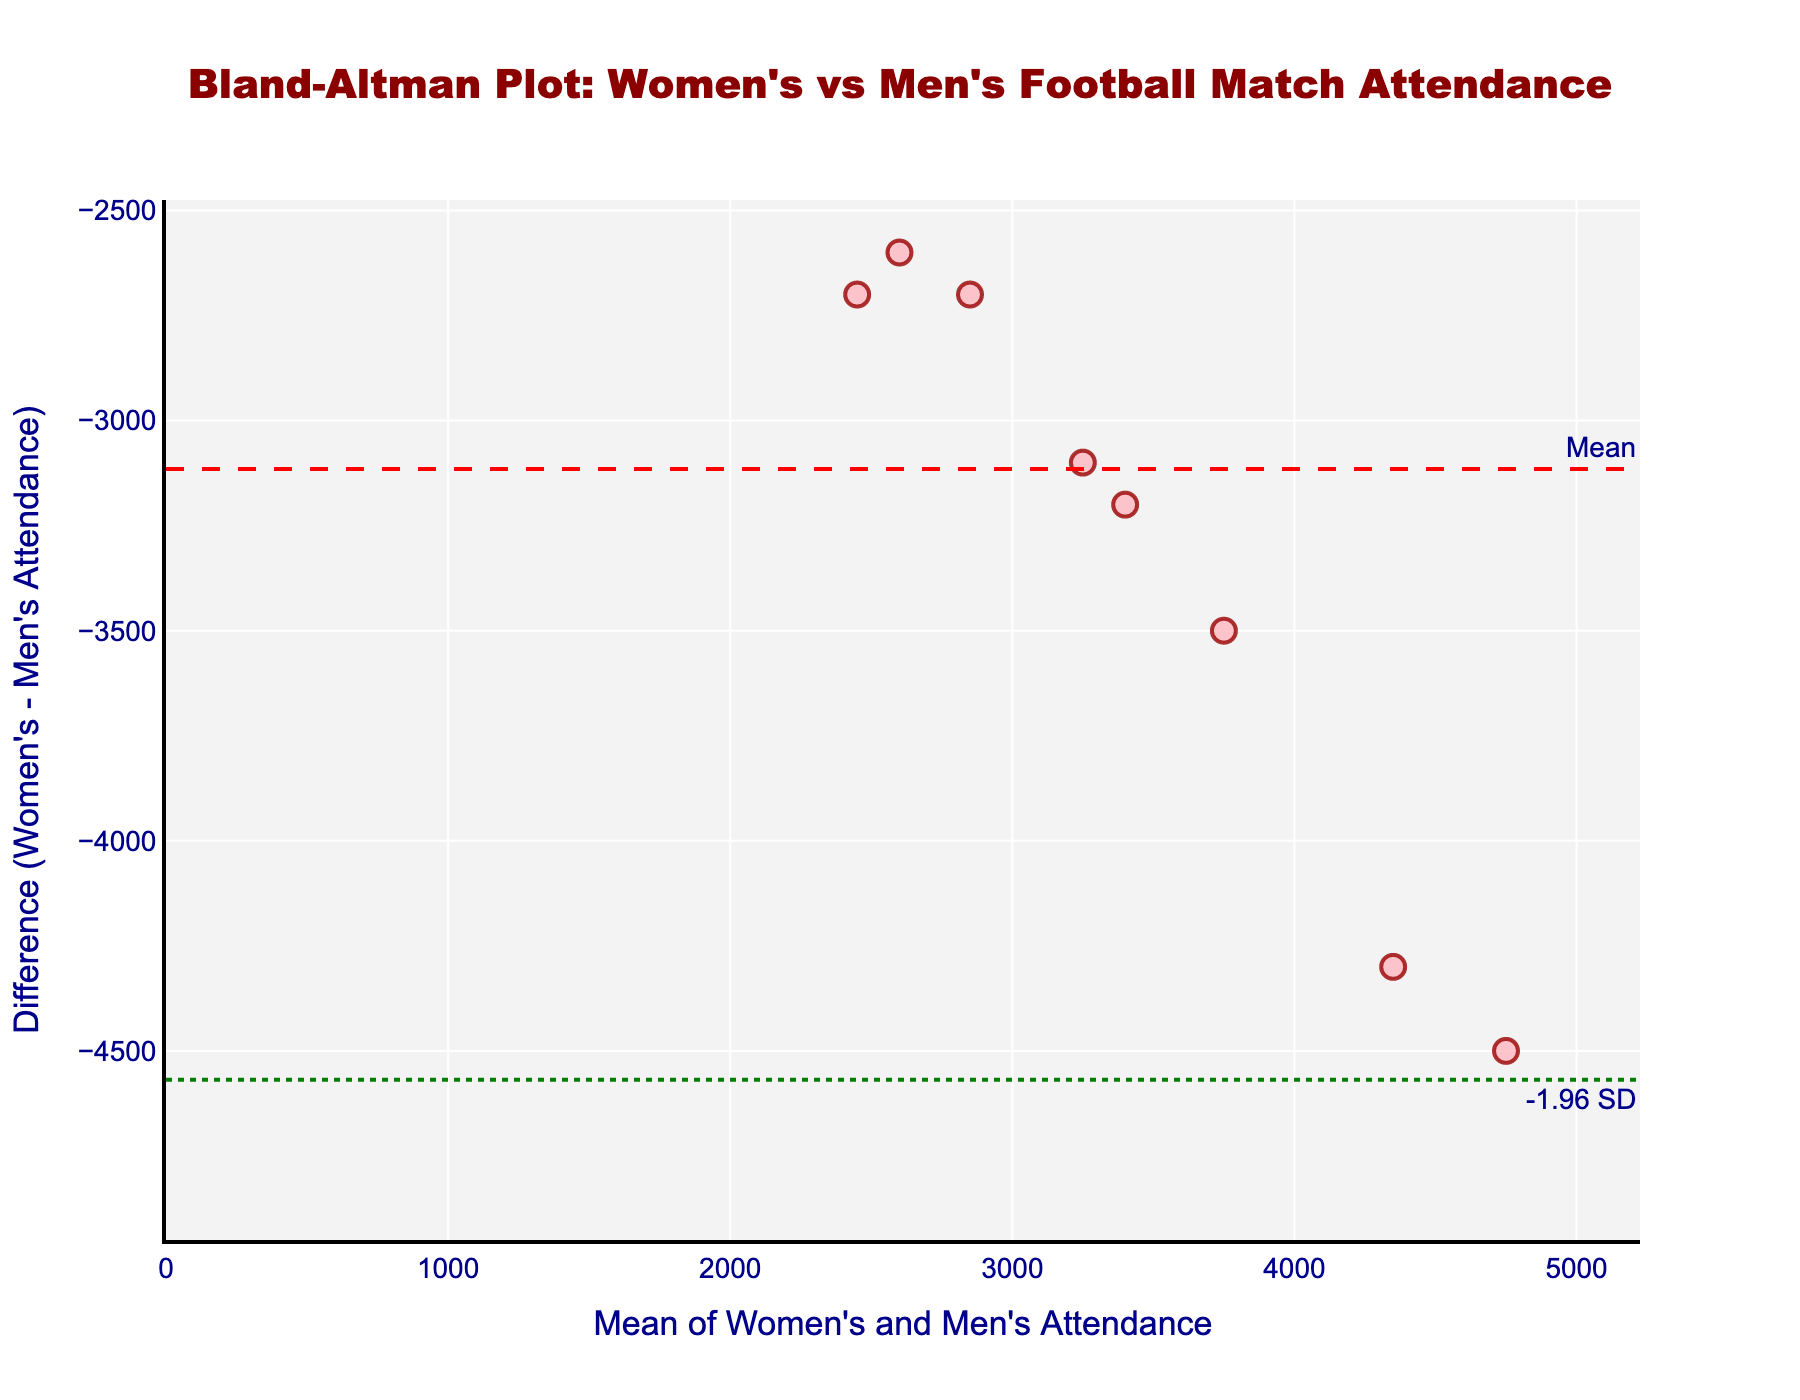What's the title of the figure? The title is located at the top center of the figure, in a larger, dark red font.
Answer: Bland-Altman Plot: Women's vs Men's Football Match Attendance How many data points are plotted in the figure? The number of data points corresponds to the number of markers on the plot. By counting, we see there are 10 markers.
Answer: 10 What is the range of values on the x-axis? The x-axis range is displayed directly on the plot. The minimum value appears to be 0, and the maximum value is slightly over 6500.
Answer: 0 to slightly over 6500 What do the green dotted lines represent? The green dotted lines are labeled with annotations as "+1.96 SD" and "-1.96 SD," indicating they represent mean ± 1.96 standard deviations of the differences.
Answer: Mean ± 1.96 SD What is the mean difference line colored, and what is its value? The mean difference line is dashed and colored red. It is a horizontal line annotated as "Mean." By tracing it on the plot, it looks like it’s around -3000.
Answer: Red, around -3000 Which match had the largest difference in attendance between women's and men's teams? This requires identifying the data point farthest away from the mean line vertically. From the plot, it appears the match "Lithuania vs Sweden" has the largest negative difference.
Answer: Lithuania vs Sweden Which matches are above the mean difference line? We need to look for markers positioned above the red line. From the plot, these matches are "Lithuania vs Latvia," "Lithuania vs Finland," "Lithuania vs Norway," and "Lithuania vs Denmark."
Answer: Lithuania vs Latvia, Lithuania vs Finland, Lithuania vs Norway, Lithuania vs Denmark What's the calculated standard deviation of the differences shown in the plot? Based on the mean and the positions of the +1.96 SD and -1.96 SD lines, we use the formula for standard deviation from these lines being at approximately 1.96 * SD away from the mean. From the values seen, SD appears roughly around 1000.
Answer: Around 1000 On average, are the attendances at women's matches higher or lower compared to men's matches? We observe that the majority of data points are below the mean difference line, indicating negative differences. This means that on average, women's match attendances are lower.
Answer: Lower 